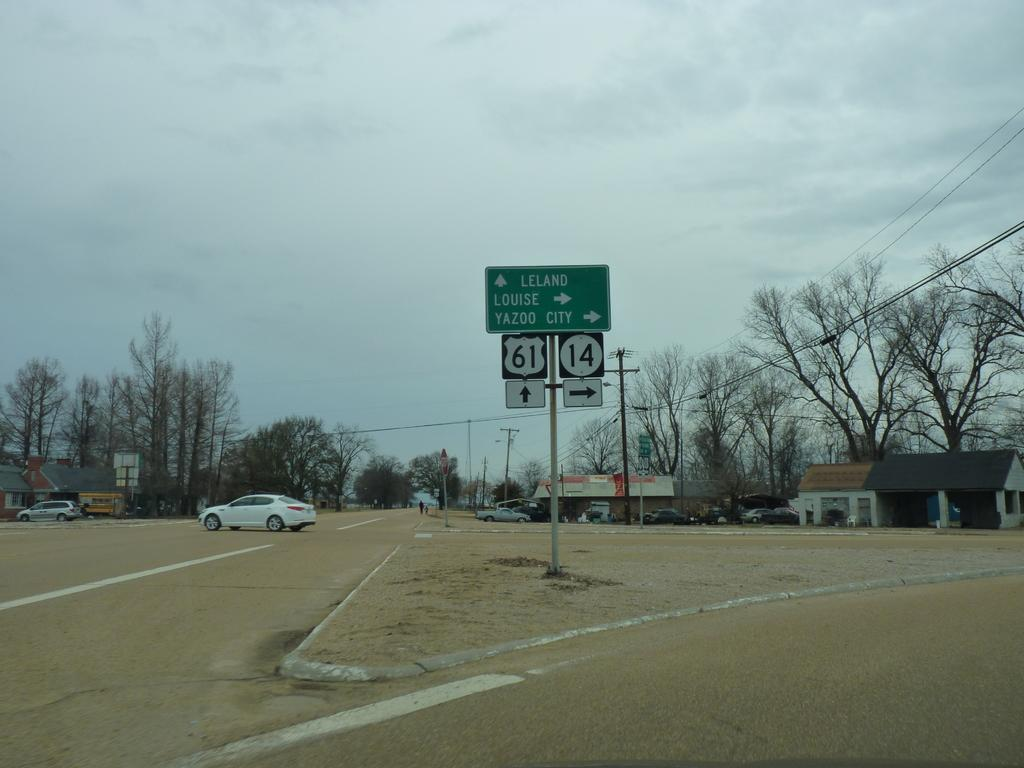<image>
Relay a brief, clear account of the picture shown. two signs with the numbers 61 and 14 on them 